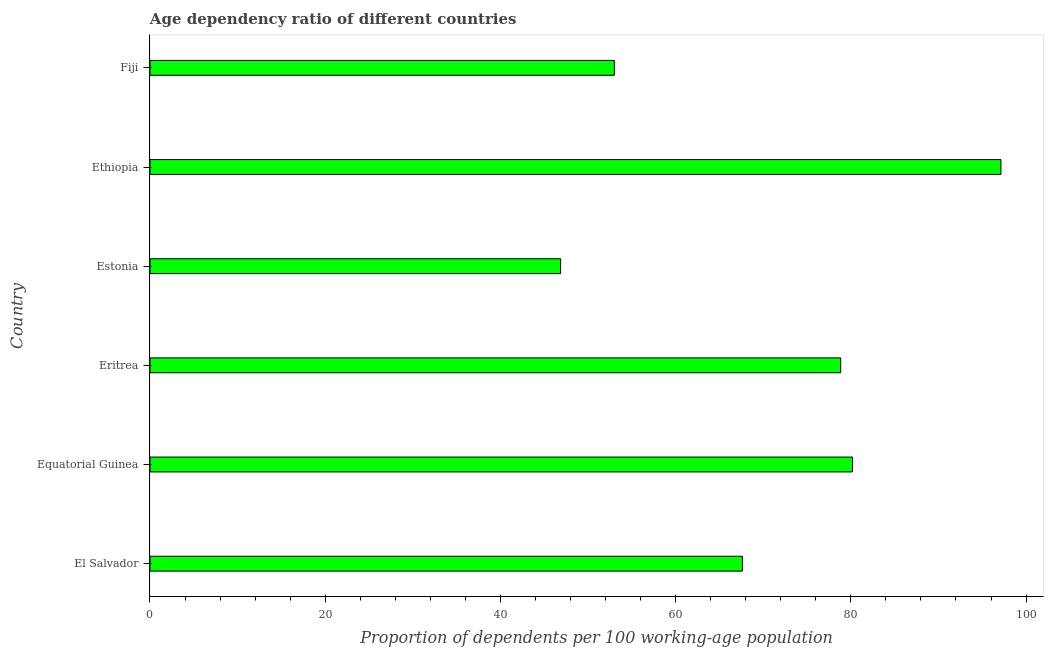Does the graph contain any zero values?
Give a very brief answer. No. What is the title of the graph?
Provide a succinct answer. Age dependency ratio of different countries. What is the label or title of the X-axis?
Provide a succinct answer. Proportion of dependents per 100 working-age population. What is the label or title of the Y-axis?
Offer a very short reply. Country. What is the age dependency ratio in Equatorial Guinea?
Keep it short and to the point. 80.19. Across all countries, what is the maximum age dependency ratio?
Make the answer very short. 97.13. Across all countries, what is the minimum age dependency ratio?
Your answer should be compact. 46.87. In which country was the age dependency ratio maximum?
Provide a short and direct response. Ethiopia. In which country was the age dependency ratio minimum?
Your answer should be very brief. Estonia. What is the sum of the age dependency ratio?
Offer a very short reply. 423.66. What is the difference between the age dependency ratio in El Salvador and Estonia?
Provide a short and direct response. 20.75. What is the average age dependency ratio per country?
Your answer should be very brief. 70.61. What is the median age dependency ratio?
Keep it short and to the point. 73.23. In how many countries, is the age dependency ratio greater than 4 ?
Your response must be concise. 6. What is the ratio of the age dependency ratio in Estonia to that in Fiji?
Keep it short and to the point. 0.88. What is the difference between the highest and the second highest age dependency ratio?
Your response must be concise. 16.95. Is the sum of the age dependency ratio in Estonia and Fiji greater than the maximum age dependency ratio across all countries?
Your response must be concise. Yes. What is the difference between the highest and the lowest age dependency ratio?
Make the answer very short. 50.26. In how many countries, is the age dependency ratio greater than the average age dependency ratio taken over all countries?
Offer a terse response. 3. Are all the bars in the graph horizontal?
Give a very brief answer. Yes. Are the values on the major ticks of X-axis written in scientific E-notation?
Keep it short and to the point. No. What is the Proportion of dependents per 100 working-age population of El Salvador?
Offer a terse response. 67.62. What is the Proportion of dependents per 100 working-age population of Equatorial Guinea?
Offer a terse response. 80.19. What is the Proportion of dependents per 100 working-age population in Eritrea?
Provide a succinct answer. 78.84. What is the Proportion of dependents per 100 working-age population in Estonia?
Ensure brevity in your answer.  46.87. What is the Proportion of dependents per 100 working-age population in Ethiopia?
Your answer should be very brief. 97.13. What is the Proportion of dependents per 100 working-age population in Fiji?
Offer a terse response. 53.01. What is the difference between the Proportion of dependents per 100 working-age population in El Salvador and Equatorial Guinea?
Your response must be concise. -12.57. What is the difference between the Proportion of dependents per 100 working-age population in El Salvador and Eritrea?
Make the answer very short. -11.22. What is the difference between the Proportion of dependents per 100 working-age population in El Salvador and Estonia?
Your answer should be very brief. 20.75. What is the difference between the Proportion of dependents per 100 working-age population in El Salvador and Ethiopia?
Provide a short and direct response. -29.51. What is the difference between the Proportion of dependents per 100 working-age population in El Salvador and Fiji?
Provide a succinct answer. 14.61. What is the difference between the Proportion of dependents per 100 working-age population in Equatorial Guinea and Eritrea?
Ensure brevity in your answer.  1.35. What is the difference between the Proportion of dependents per 100 working-age population in Equatorial Guinea and Estonia?
Ensure brevity in your answer.  33.32. What is the difference between the Proportion of dependents per 100 working-age population in Equatorial Guinea and Ethiopia?
Your answer should be compact. -16.95. What is the difference between the Proportion of dependents per 100 working-age population in Equatorial Guinea and Fiji?
Give a very brief answer. 27.18. What is the difference between the Proportion of dependents per 100 working-age population in Eritrea and Estonia?
Your answer should be compact. 31.97. What is the difference between the Proportion of dependents per 100 working-age population in Eritrea and Ethiopia?
Offer a very short reply. -18.29. What is the difference between the Proportion of dependents per 100 working-age population in Eritrea and Fiji?
Your answer should be very brief. 25.84. What is the difference between the Proportion of dependents per 100 working-age population in Estonia and Ethiopia?
Your answer should be very brief. -50.26. What is the difference between the Proportion of dependents per 100 working-age population in Estonia and Fiji?
Keep it short and to the point. -6.13. What is the difference between the Proportion of dependents per 100 working-age population in Ethiopia and Fiji?
Your answer should be compact. 44.13. What is the ratio of the Proportion of dependents per 100 working-age population in El Salvador to that in Equatorial Guinea?
Offer a very short reply. 0.84. What is the ratio of the Proportion of dependents per 100 working-age population in El Salvador to that in Eritrea?
Offer a terse response. 0.86. What is the ratio of the Proportion of dependents per 100 working-age population in El Salvador to that in Estonia?
Your response must be concise. 1.44. What is the ratio of the Proportion of dependents per 100 working-age population in El Salvador to that in Ethiopia?
Your response must be concise. 0.7. What is the ratio of the Proportion of dependents per 100 working-age population in El Salvador to that in Fiji?
Your response must be concise. 1.28. What is the ratio of the Proportion of dependents per 100 working-age population in Equatorial Guinea to that in Estonia?
Your response must be concise. 1.71. What is the ratio of the Proportion of dependents per 100 working-age population in Equatorial Guinea to that in Ethiopia?
Keep it short and to the point. 0.83. What is the ratio of the Proportion of dependents per 100 working-age population in Equatorial Guinea to that in Fiji?
Your response must be concise. 1.51. What is the ratio of the Proportion of dependents per 100 working-age population in Eritrea to that in Estonia?
Offer a very short reply. 1.68. What is the ratio of the Proportion of dependents per 100 working-age population in Eritrea to that in Ethiopia?
Provide a short and direct response. 0.81. What is the ratio of the Proportion of dependents per 100 working-age population in Eritrea to that in Fiji?
Provide a succinct answer. 1.49. What is the ratio of the Proportion of dependents per 100 working-age population in Estonia to that in Ethiopia?
Offer a terse response. 0.48. What is the ratio of the Proportion of dependents per 100 working-age population in Estonia to that in Fiji?
Ensure brevity in your answer.  0.88. What is the ratio of the Proportion of dependents per 100 working-age population in Ethiopia to that in Fiji?
Provide a short and direct response. 1.83. 